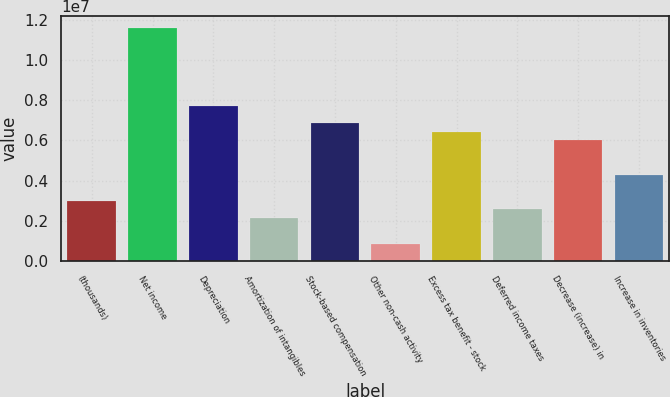Convert chart. <chart><loc_0><loc_0><loc_500><loc_500><bar_chart><fcel>(thousands)<fcel>Net income<fcel>Depreciation<fcel>Amortization of intangibles<fcel>Stock-based compensation<fcel>Other non-cash activity<fcel>Excess tax benefit - stock<fcel>Deferred income taxes<fcel>Decrease (increase) in<fcel>Increase in inventories<nl><fcel>3.0026e+06<fcel>1.15806e+07<fcel>7.7205e+06<fcel>2.1448e+06<fcel>6.8627e+06<fcel>858103<fcel>6.4338e+06<fcel>2.5737e+06<fcel>6.0049e+06<fcel>4.2893e+06<nl></chart> 